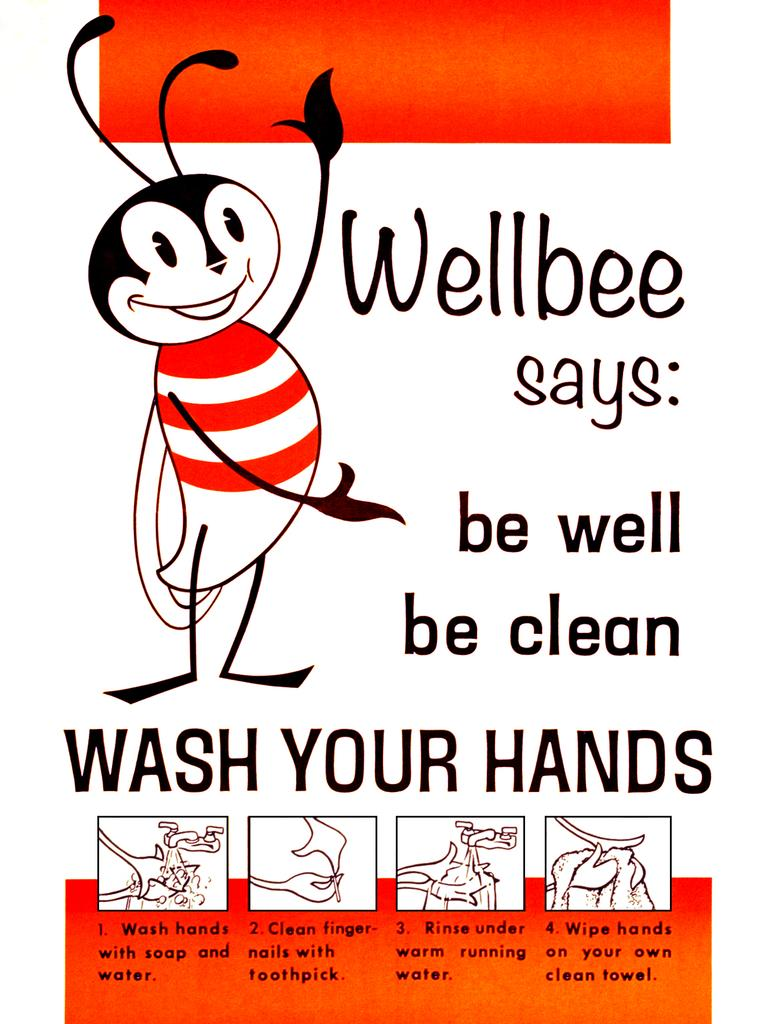What type of creature can be seen in the image? There is an insect in the image. What else can be seen in the image besides the insect? There are other things in the image. Is there any text present in the image? Yes, there is text written on the image. Can you see the insect kicking a soccer ball in the image? No, there is no soccer ball or any indication of the insect kicking in the image. 